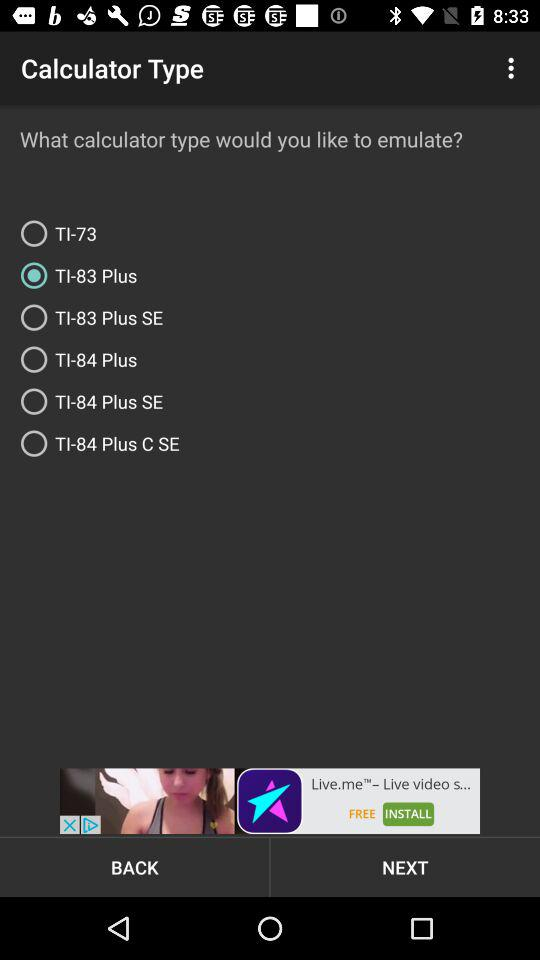How many calculator types are available to emulate?
Answer the question using a single word or phrase. 6 